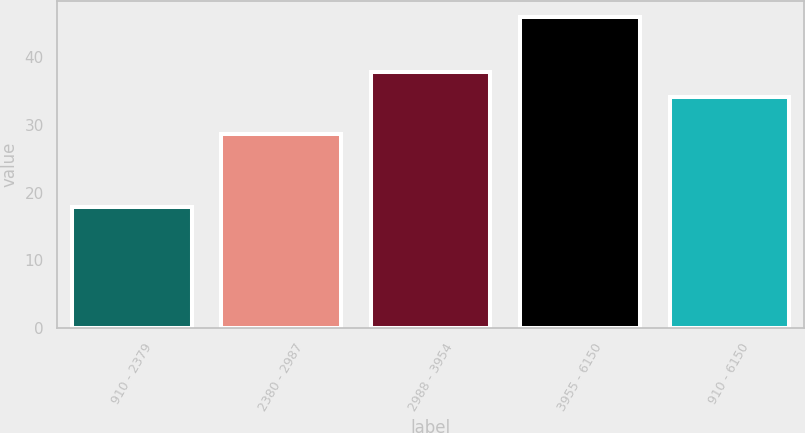Convert chart. <chart><loc_0><loc_0><loc_500><loc_500><bar_chart><fcel>910 - 2379<fcel>2380 - 2987<fcel>2988 - 3954<fcel>3955 - 6150<fcel>910 - 6150<nl><fcel>17.86<fcel>28.61<fcel>37.9<fcel>46.02<fcel>34.15<nl></chart> 